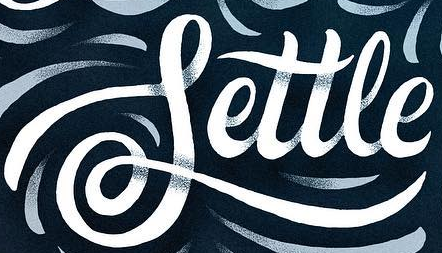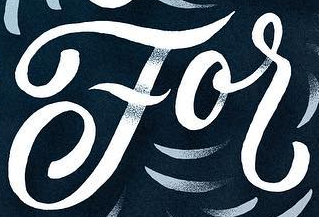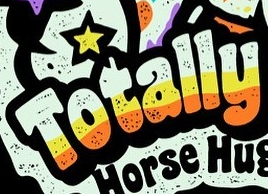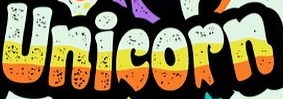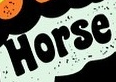Read the text content from these images in order, separated by a semicolon. Settle; For; Totally; Unicorn; Horse 